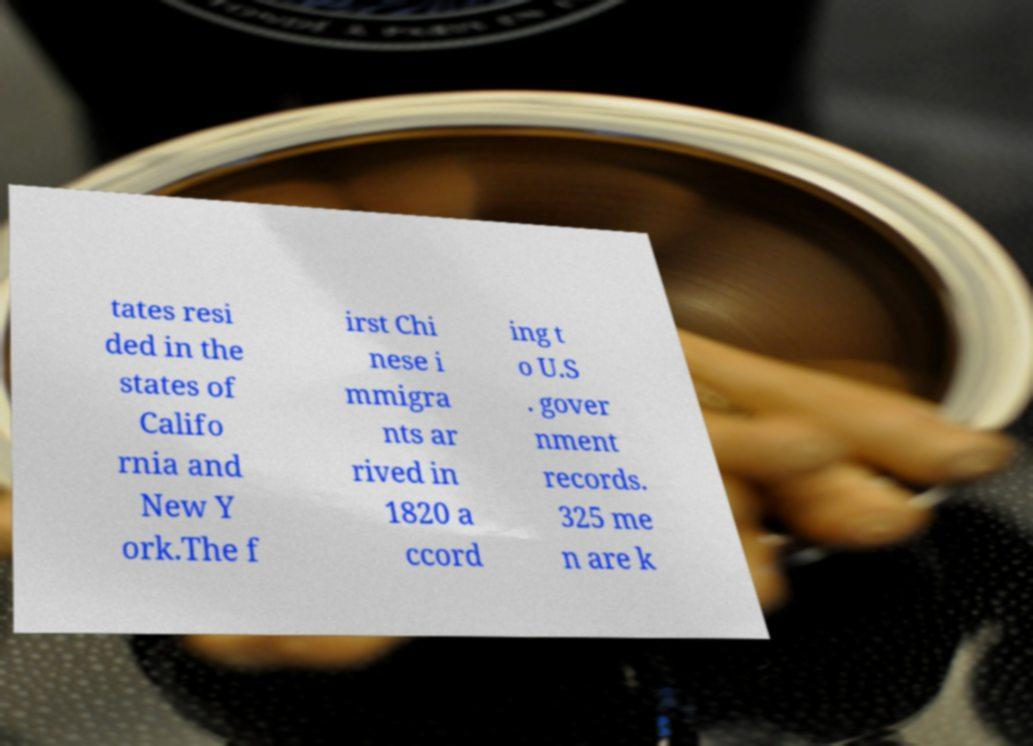For documentation purposes, I need the text within this image transcribed. Could you provide that? tates resi ded in the states of Califo rnia and New Y ork.The f irst Chi nese i mmigra nts ar rived in 1820 a ccord ing t o U.S . gover nment records. 325 me n are k 